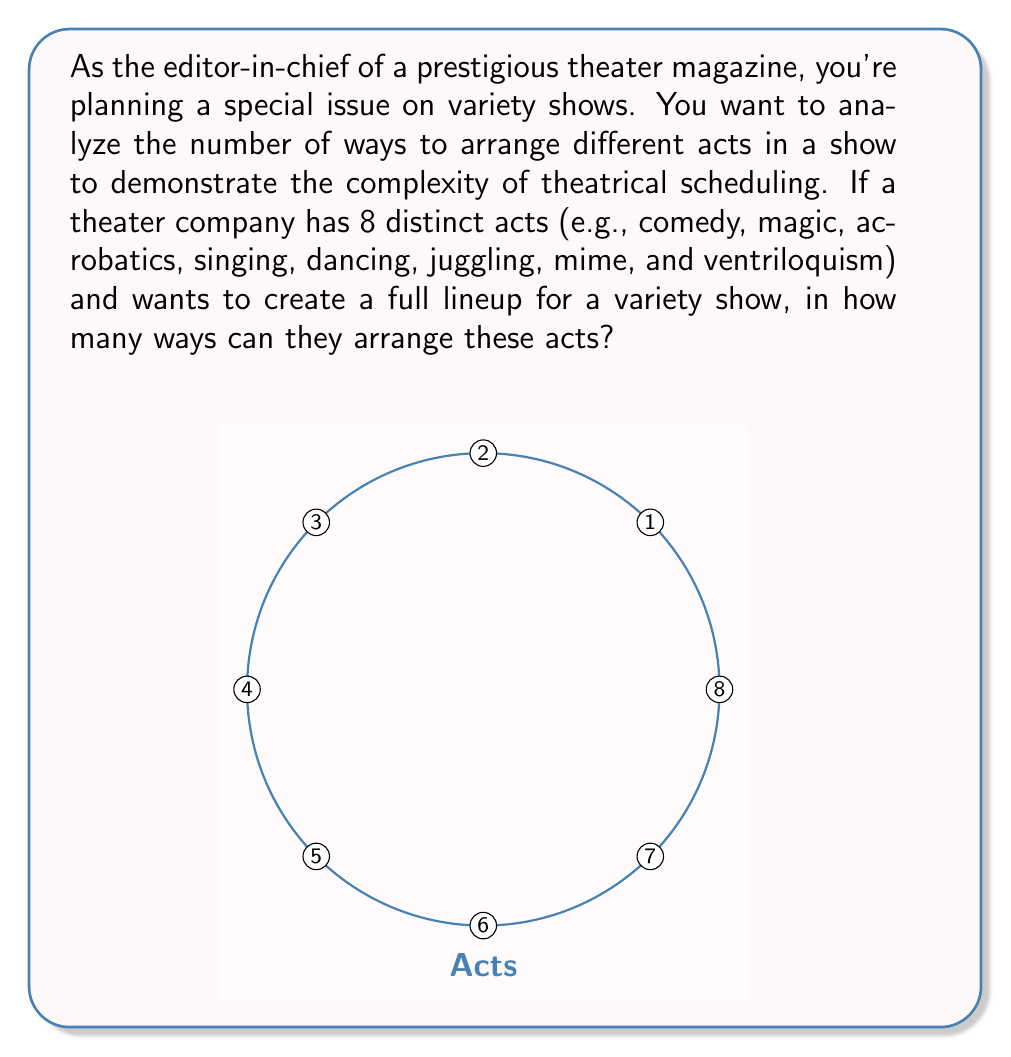Could you help me with this problem? To solve this problem, we need to understand that this is a permutation question. We are arranging all 8 acts in a specific order, and each act is used exactly once.

1) In permutation problems, the number of ways to arrange n distinct objects is given by n!

2) In this case, we have 8 distinct acts, so n = 8

3) Therefore, the number of ways to arrange these acts is 8!

4) Let's calculate 8!:
   
   $$8! = 8 \times 7 \times 6 \times 5 \times 4 \times 3 \times 2 \times 1$$

5) Multiplying these numbers:
   
   $$8! = 40,320$$

This result shows the vast number of possibilities a theater director has when arranging acts for a variety show, highlighting the importance of understanding theatrical scheduling and its impact on the overall performance structure.
Answer: $40,320$ 